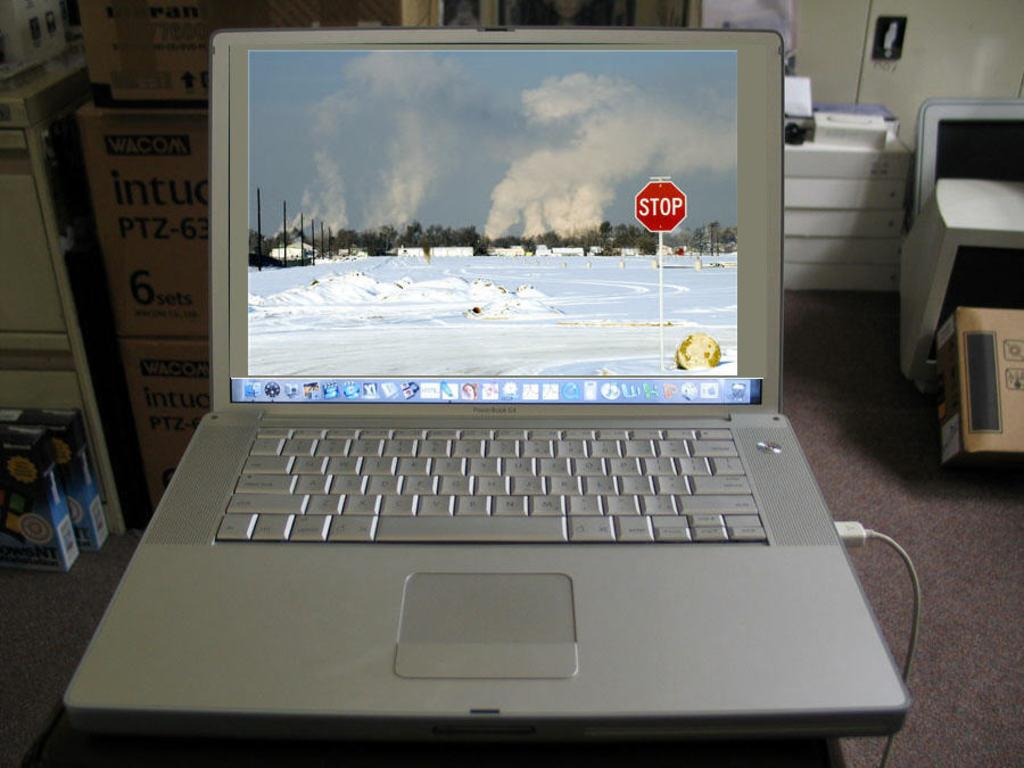<image>
Render a clear and concise summary of the photo. A silver laptop is open showing a winter scene and stop sign background. 